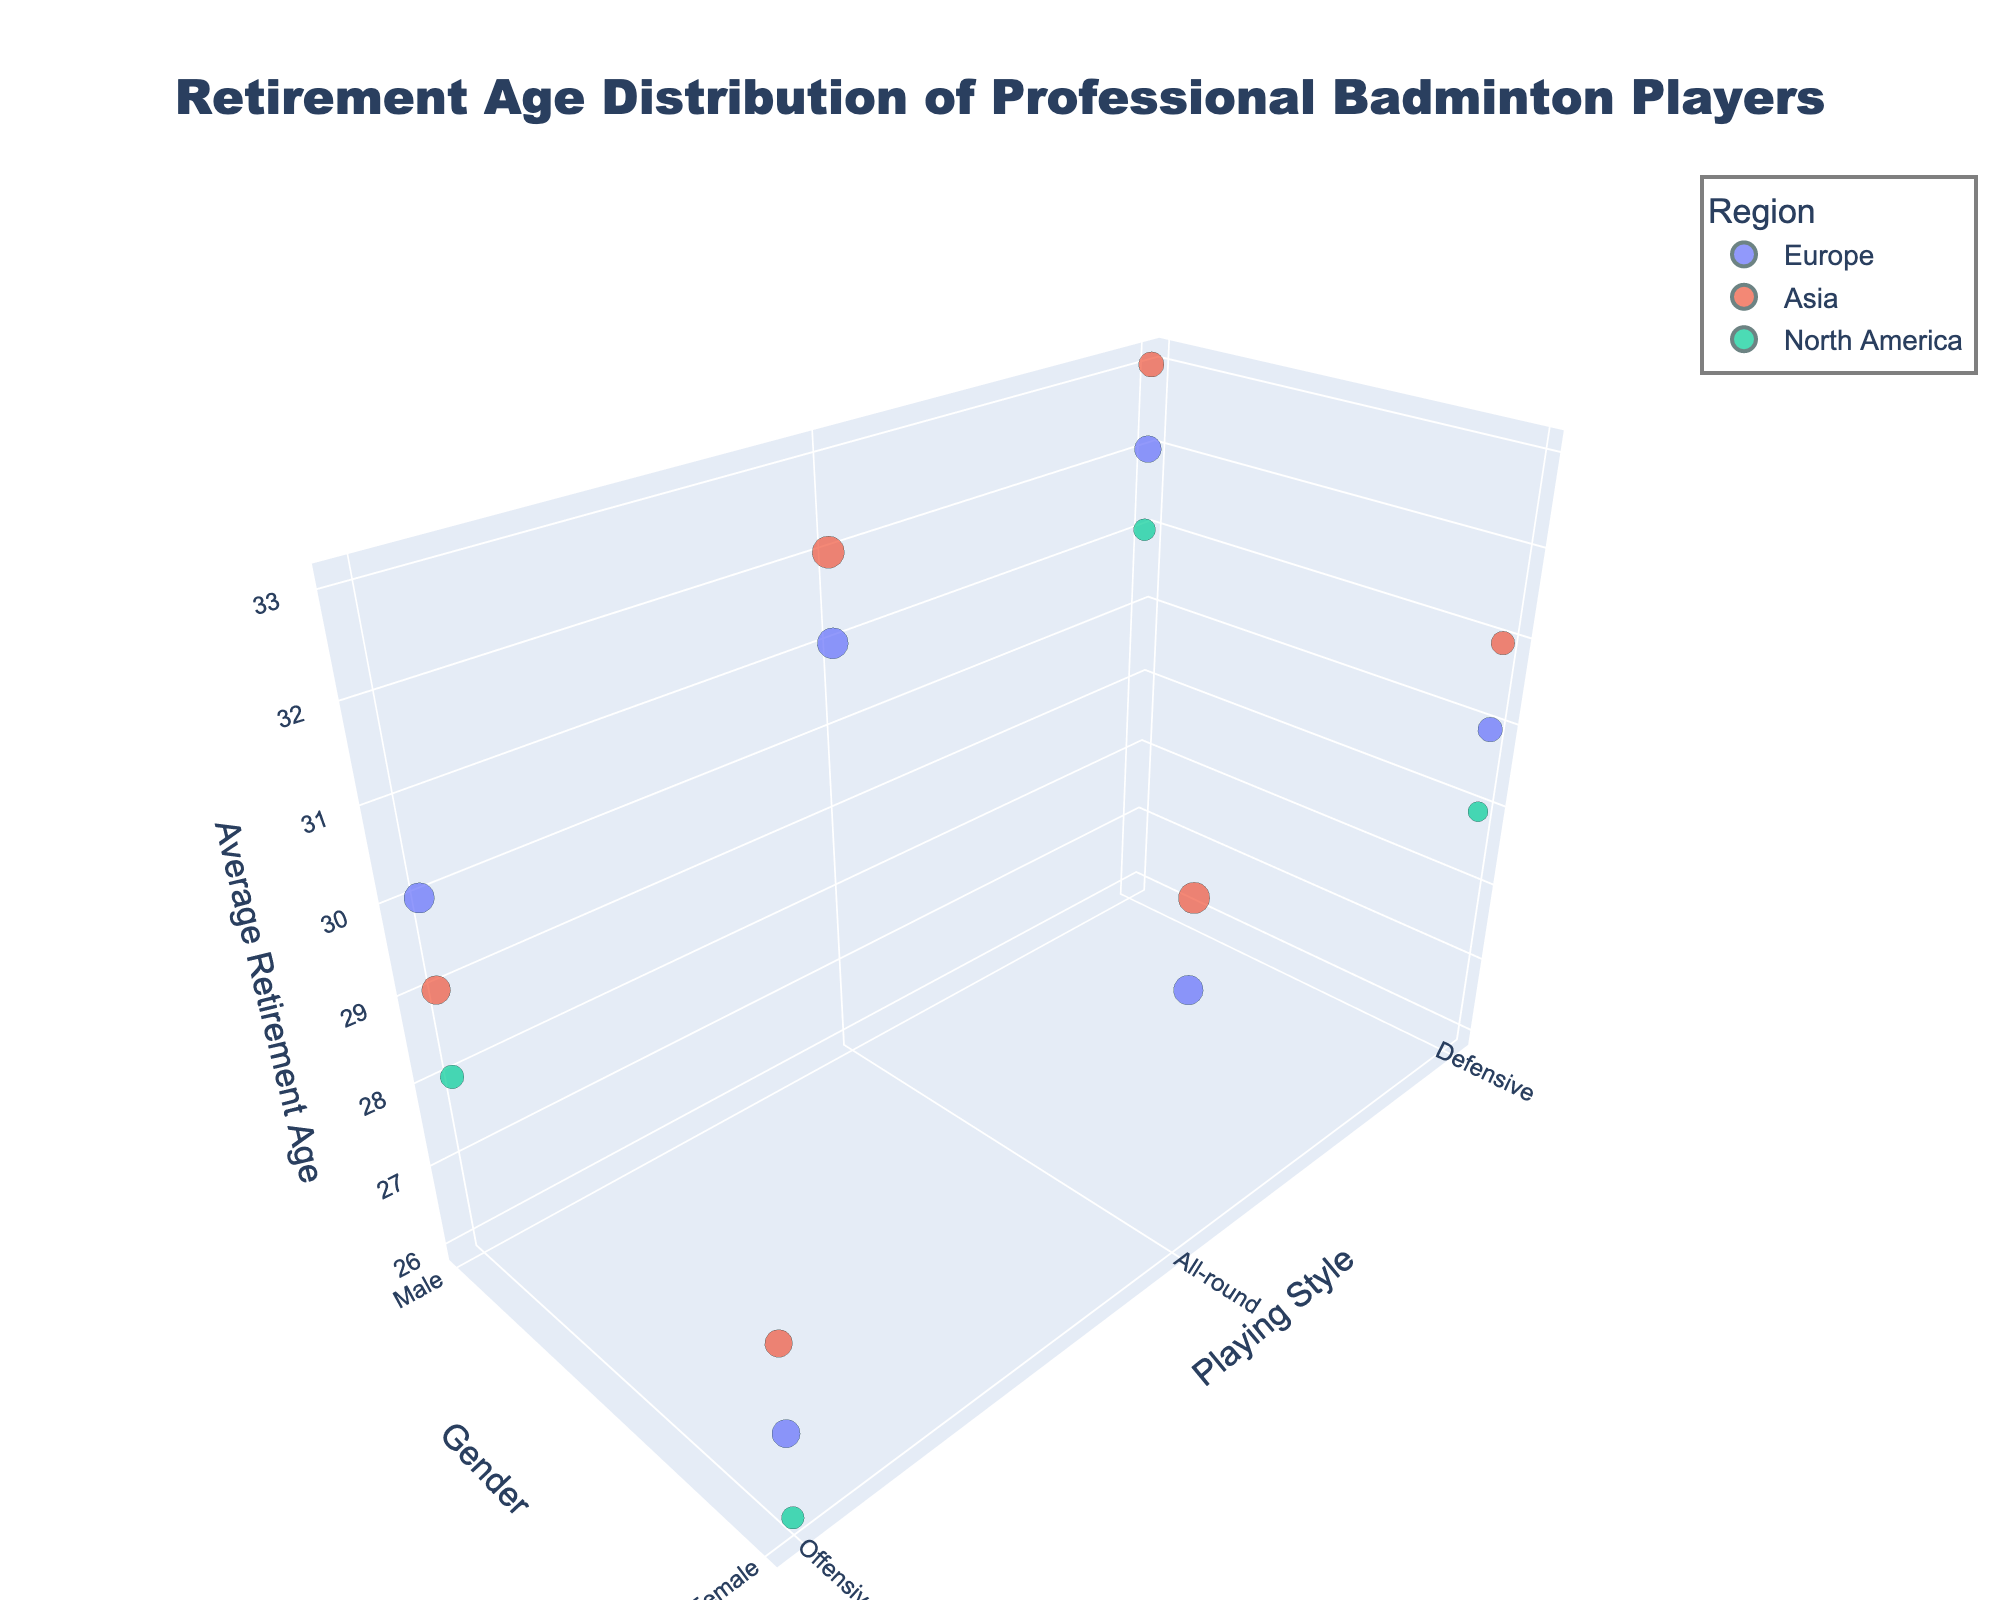How many regions are represented in the chart? By examining the colored bubbles and the legend, we can see there are four different regions: Europe, Asia, North America, and an implicit fourth region potentially outside the visible legend
Answer: 4 Which playing style has the highest average retirement age for male players? By looking at the highest point on the z-axis for male players (moving along the y-axis), we see that Defensive play style in Asia has the highest average retirement age
Answer: Defensive Which region has the largest number of players for female all-round players? By examining the size of the bubbles for female all-round players and referring to the corresponding regions, we see that Asia has the largest bubble
Answer: Asia What is the average retirement age for female offensive players in North America? Locate the bubbles representing female offensive players in North America on the chart and read the value on the z-axis, which is 26 years
Answer: 26 Compare the average retirement ages of defensive male and female players in Europe. Locate the bubbles for defensive male and female players in Europe and compare their z-axis values: 32 for males and 30 for females
Answer: Male players retire 2 years later on average Which group has a more balanced number of players between genders, all-round players in Europe or Asia? By comparing the size of the bubbles for all-round male and female players in Europe and Asia, it's evident that Europe has closer bubble sizes (males: 60, females: 55), compared to Asia (males: 65, females: 62)
Answer: Europe How does the average retirement age for male offensive players in North America compare to Europe? Compare the z-axis values for male offensive players in North America and Europe: 28 for North America and 30 for Europe
Answer: Europe is 2 years higher What's the average retirement age of male players across all regions? Sum the average retirement ages for male players across all regions and divide by the number of data points. (32+29+31+33+30+28)/6 = 183/6 = 30.5
Answer: 30.5 Which region has the highest number of defensive female players? Locate the bubbles associated with defensive female players and compare their sizes. Europe (38), Asia (35), North America (25) - Europe has the largest bubble
Answer: Europe Which gender has a higher average retirement age for all-round players in Asia? Compare the z-axis values for male and female all-round players in Asia: 32 for males and 30 for females
Answer: Male players 